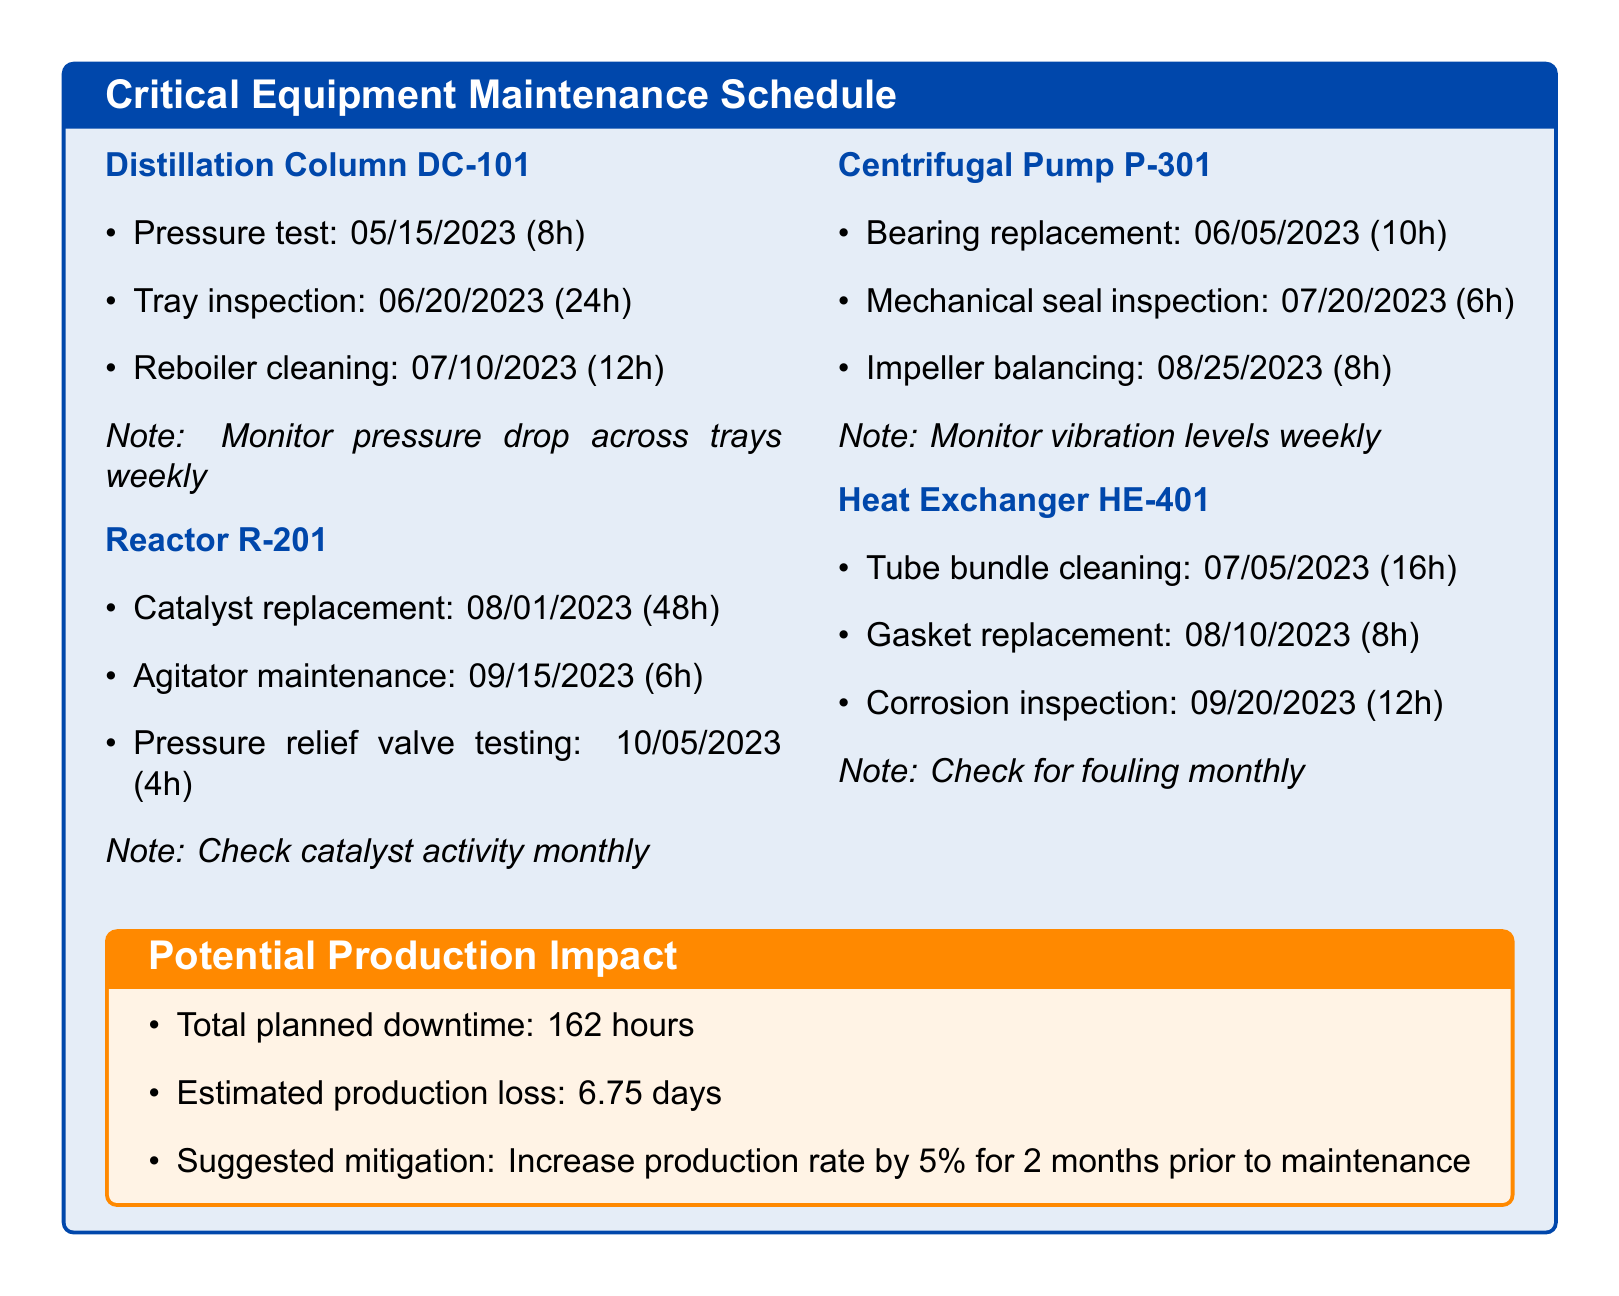what is the next task scheduled for Distillation Column DC-101? The next task for Distillation Column DC-101 is Tray inspection scheduled for 06/20/2023.
Answer: Tray inspection: 06/20/2023 how many hours of downtime is associated with the Catalyst replacement for Reactor R-201? Catalyst replacement for Reactor R-201 is scheduled to have 48 hours of downtime.
Answer: 48 hours what is the total planned downtime for all critical equipment? The document states that the total planned downtime is 162 hours.
Answer: 162 hours when is the Bearing replacement for Centrifugal Pump P-301 scheduled? The Bearing replacement is scheduled for 06/05/2023.
Answer: 06/05/2023 what preventive maintenance task is due next for Heat Exchanger HE-401? The next task due for Heat Exchanger HE-401 is Tube bundle cleaning on 07/05/2023.
Answer: Tube bundle cleaning: 07/05/2023 how many days of production loss is estimated due to planned downtime? The estimated production loss due to planned downtime is 6.75 days.
Answer: 6.75 days what note is mentioned for monitoring the Distillation Column DC-101? The note states to monitor the pressure drop across trays weekly.
Answer: Monitor pressure drop across trays weekly which task requires the least amount of downtime for Reactor R-201? The task that requires the least amount of downtime for Reactor R-201 is Pressure relief valve testing with 4 hours downtime.
Answer: 4 hours what is the suggested mitigation strategy for the production impact? The suggested mitigation strategy is to increase production rate by 5% for 2 months prior to maintenance.
Answer: Increase production rate by 5% for 2 months prior to maintenance 